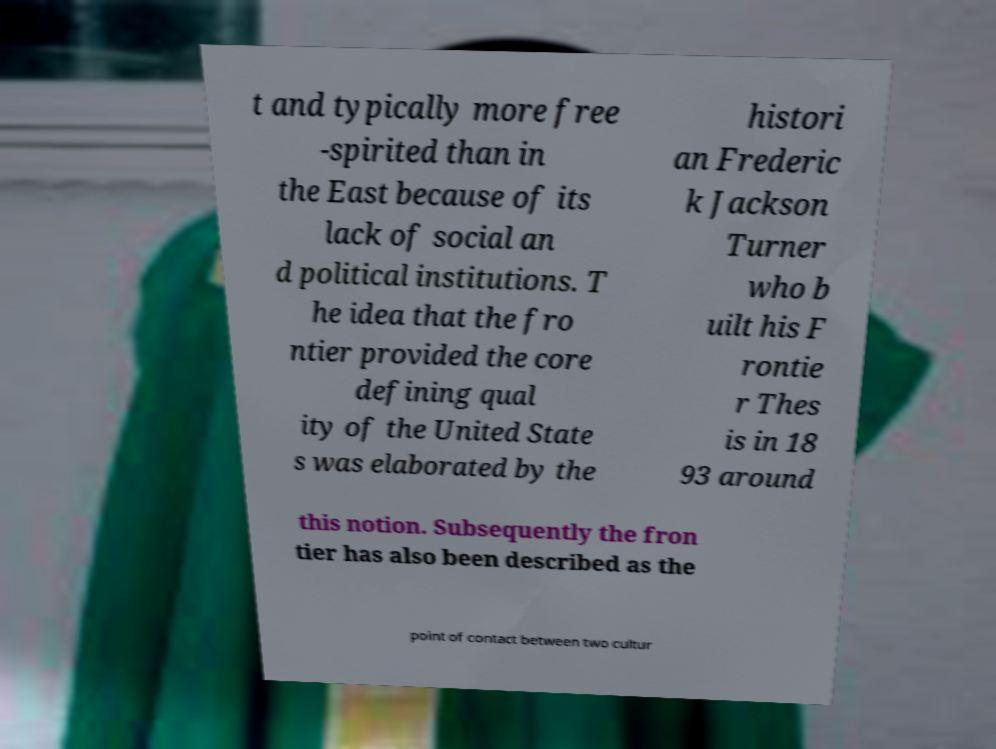I need the written content from this picture converted into text. Can you do that? t and typically more free -spirited than in the East because of its lack of social an d political institutions. T he idea that the fro ntier provided the core defining qual ity of the United State s was elaborated by the histori an Frederic k Jackson Turner who b uilt his F rontie r Thes is in 18 93 around this notion. Subsequently the fron tier has also been described as the point of contact between two cultur 